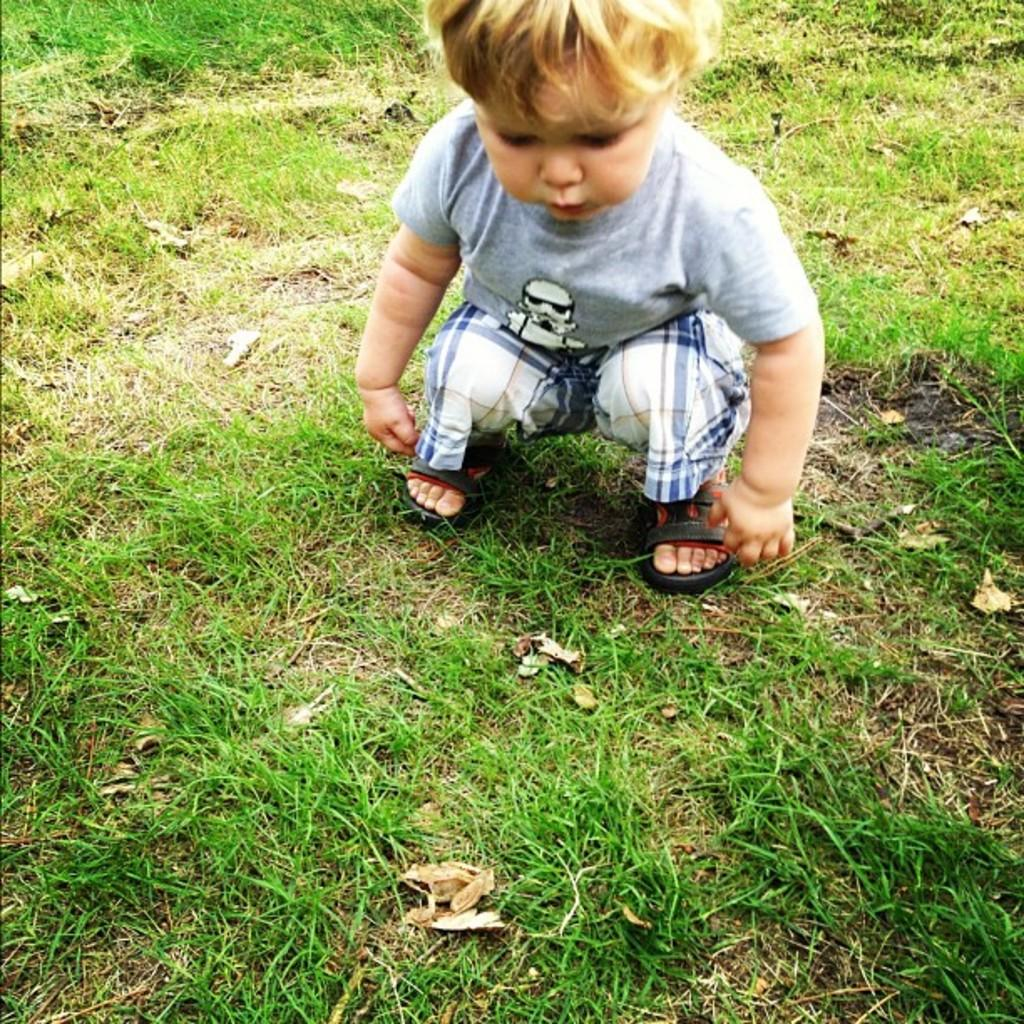What is the main subject of the image? The main subject of the image is a small boy. How is the boy positioned in the image? The boy is sitting in a squatting position. What type of surface is the boy sitting on? The boy is sitting on the grass. What type of drug is the boy holding in the image? There is no drug present in the image; the boy is simply sitting on the grass. Is the boy involved in any trade activities in the image? There is no indication of any trade activities in the image; the boy is just sitting on the grass. 